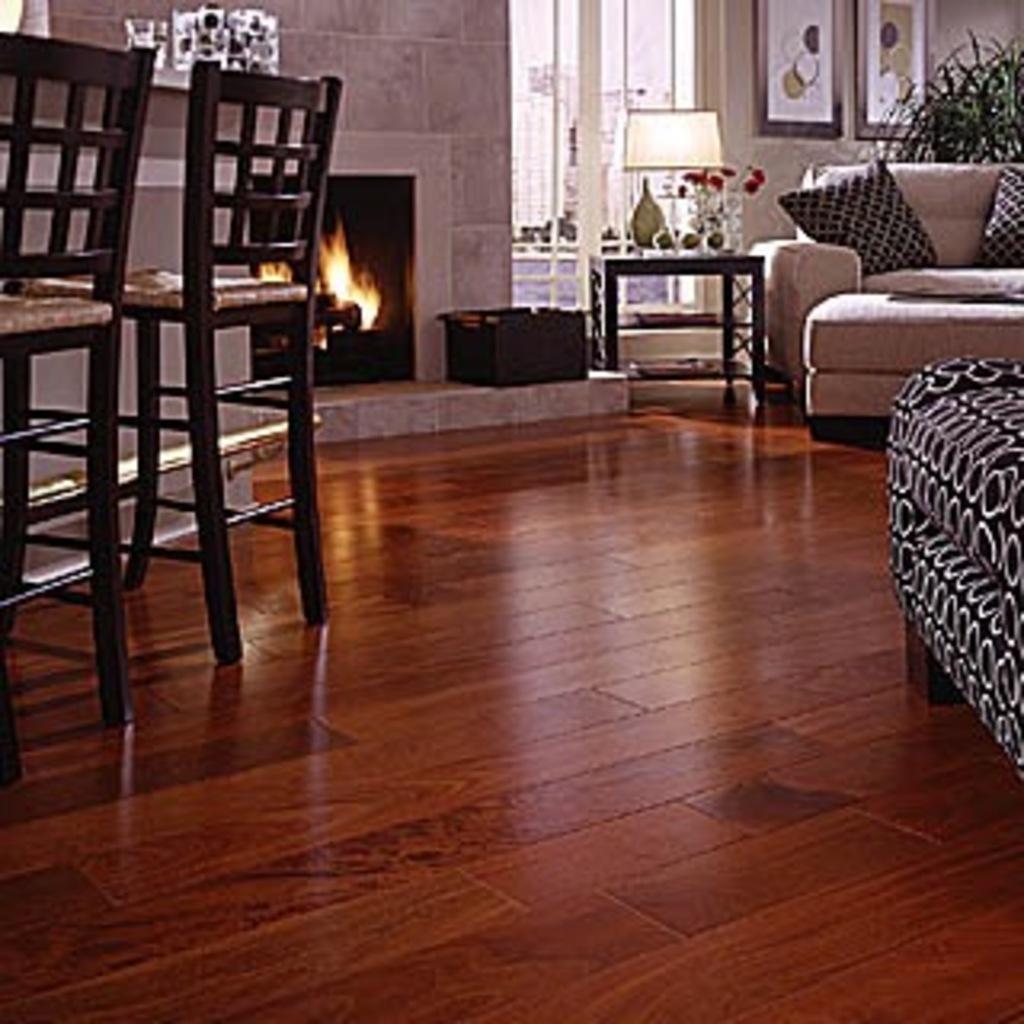Could you give a brief overview of what you see in this image? In this picture we can see an inside view of a room, on the left side there are two chairs and fireplace, on right side we can see a sofa, pillows and a plant, there is a table in the middle, we can see a lamp on the table, in the background there is a wall, there are two portraits on the wall, we can also see a door in the background. 